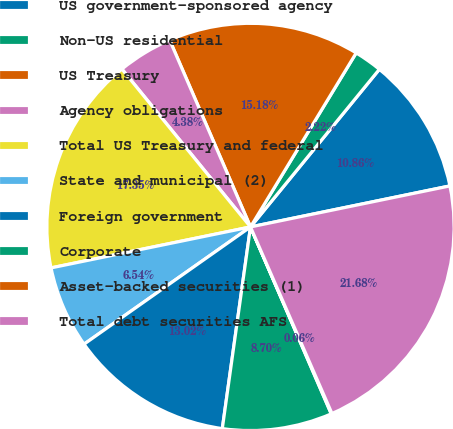<chart> <loc_0><loc_0><loc_500><loc_500><pie_chart><fcel>US government-sponsored agency<fcel>Non-US residential<fcel>US Treasury<fcel>Agency obligations<fcel>Total US Treasury and federal<fcel>State and municipal (2)<fcel>Foreign government<fcel>Corporate<fcel>Asset-backed securities (1)<fcel>Total debt securities AFS<nl><fcel>10.86%<fcel>2.22%<fcel>15.18%<fcel>4.38%<fcel>17.34%<fcel>6.54%<fcel>13.02%<fcel>8.7%<fcel>0.06%<fcel>21.67%<nl></chart> 